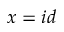<formula> <loc_0><loc_0><loc_500><loc_500>x = i d</formula> 